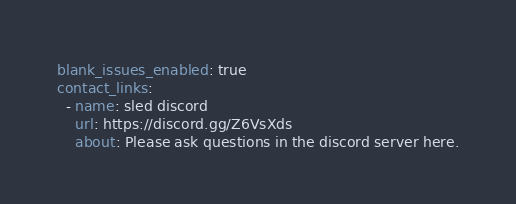Convert code to text. <code><loc_0><loc_0><loc_500><loc_500><_YAML_>blank_issues_enabled: true
contact_links:
  - name: sled discord
    url: https://discord.gg/Z6VsXds
    about: Please ask questions in the discord server here.
</code> 